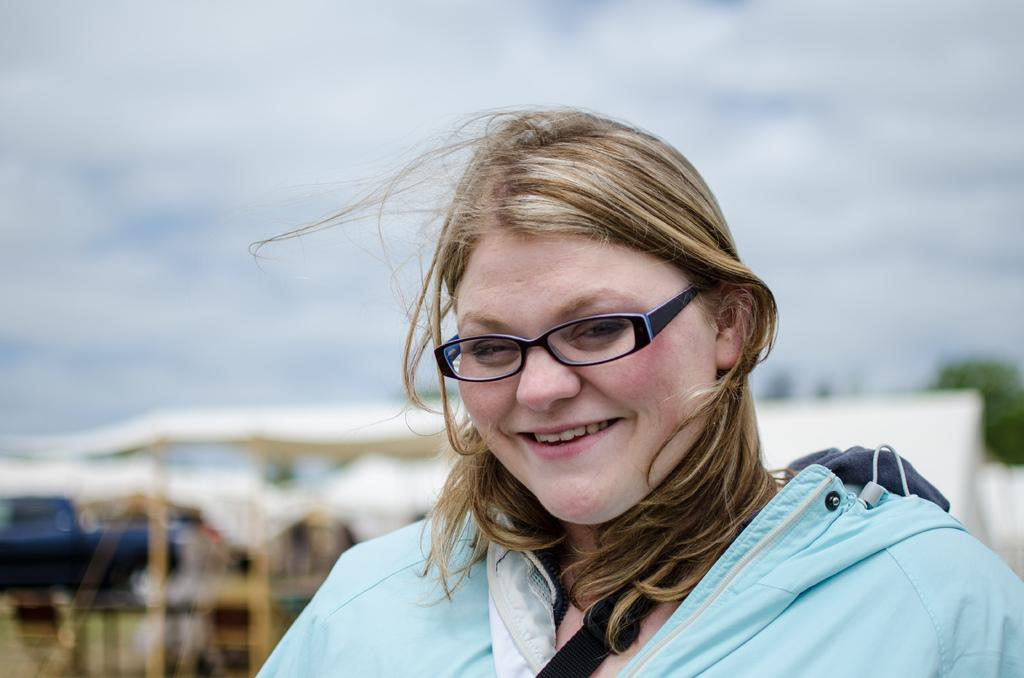Who is present in the image? There is a woman in the image. What is the woman doing in the image? The woman is smiling in the image. What is the woman wearing in the image? The woman is wearing a blue coat and black spectacles in the image. What is the weather like in the image? The sky is cloudy in the image. How many basketballs can be seen in the image? There are no basketballs present in the image. What type of knowledge is the woman sharing in the image? The image does not show the woman sharing any knowledge, as it only depicts her smiling and wearing a blue coat and black spectacles. 